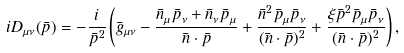Convert formula to latex. <formula><loc_0><loc_0><loc_500><loc_500>i D _ { \mu \nu } ( \bar { p } ) = - \frac { i } { \bar { p } ^ { 2 } } \left ( \bar { g } _ { \mu \nu } - \frac { \bar { n } _ { \mu } \bar { p } _ { \nu } + \bar { n } _ { \nu } \bar { p } _ { \mu } } { \bar { n } \cdot \bar { p } } + \frac { \bar { n } ^ { 2 } \bar { p } _ { \mu } \bar { p } _ { \nu } } { ( \bar { n } \cdot \bar { p } ) ^ { 2 } } + \frac { \xi \bar { p } ^ { 2 } \bar { p } _ { \mu } \bar { p } _ { \nu } } { ( \bar { n } \cdot \bar { p } ) ^ { 2 } } \right ) ,</formula> 